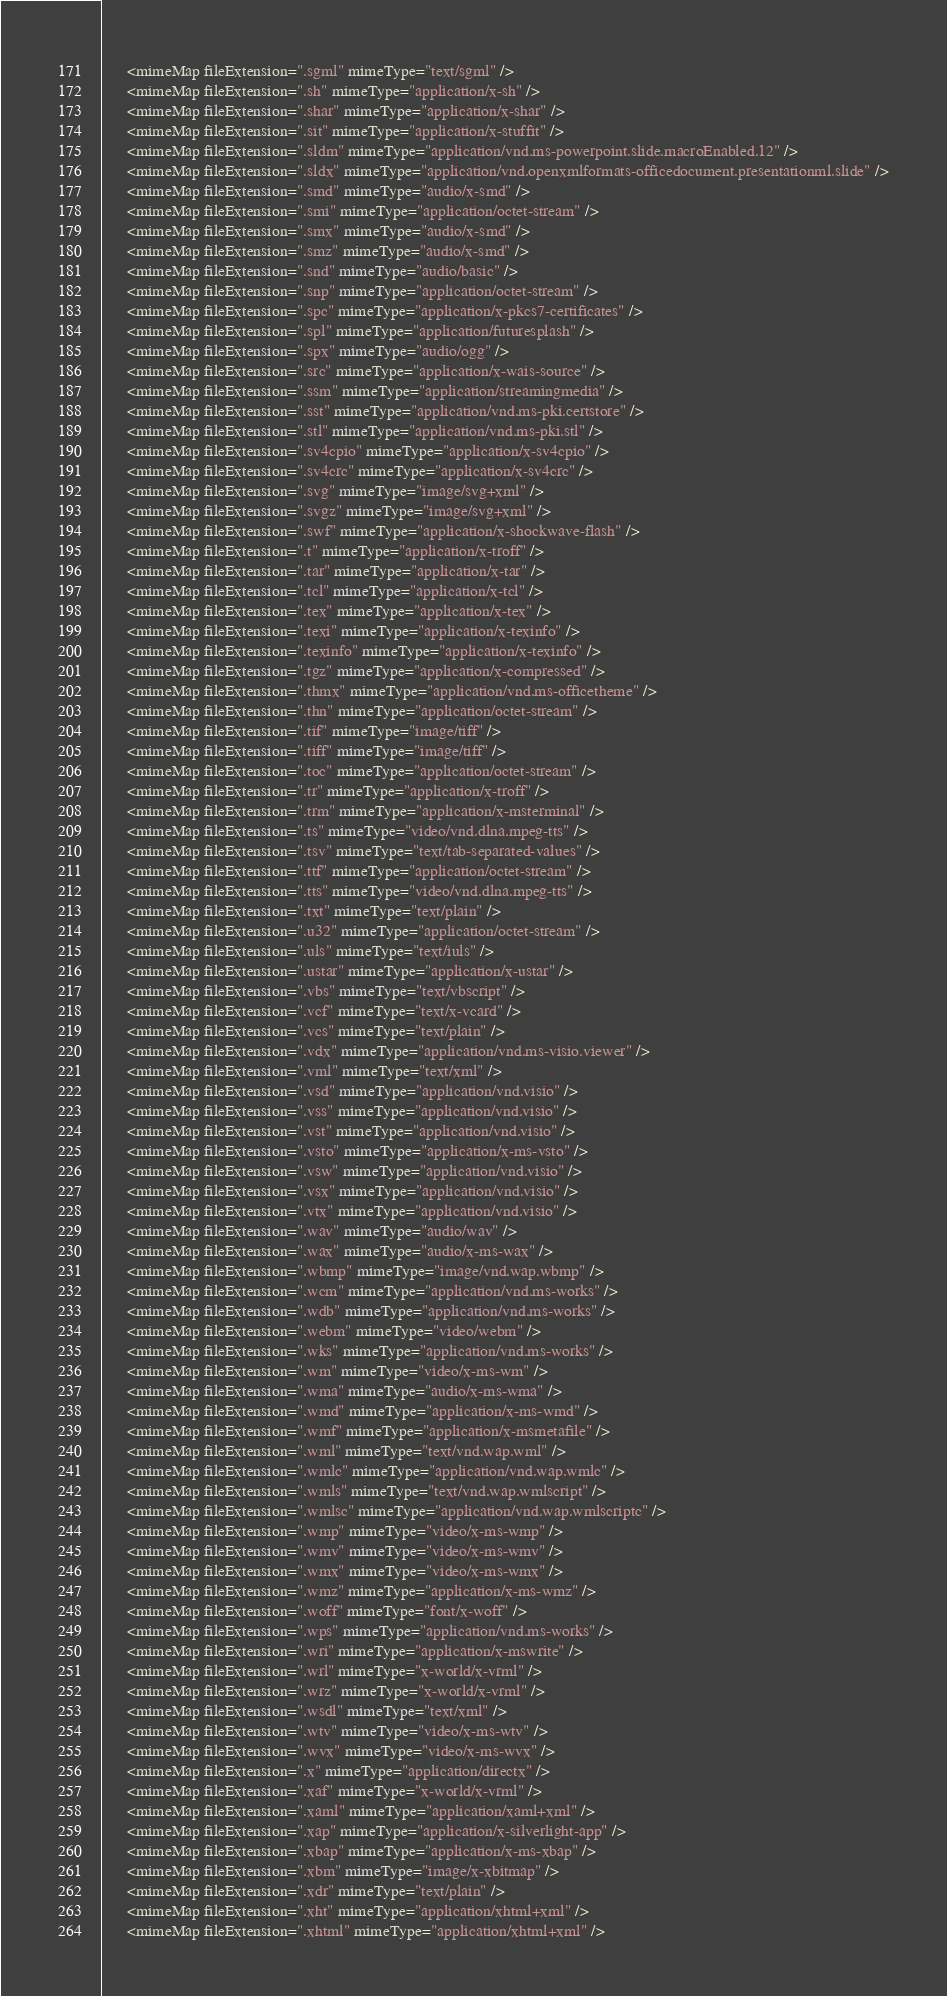Convert code to text. <code><loc_0><loc_0><loc_500><loc_500><_Go_>      <mimeMap fileExtension=".sgml" mimeType="text/sgml" />
      <mimeMap fileExtension=".sh" mimeType="application/x-sh" />
      <mimeMap fileExtension=".shar" mimeType="application/x-shar" />
      <mimeMap fileExtension=".sit" mimeType="application/x-stuffit" />
      <mimeMap fileExtension=".sldm" mimeType="application/vnd.ms-powerpoint.slide.macroEnabled.12" />
      <mimeMap fileExtension=".sldx" mimeType="application/vnd.openxmlformats-officedocument.presentationml.slide" />
      <mimeMap fileExtension=".smd" mimeType="audio/x-smd" />
      <mimeMap fileExtension=".smi" mimeType="application/octet-stream" />
      <mimeMap fileExtension=".smx" mimeType="audio/x-smd" />
      <mimeMap fileExtension=".smz" mimeType="audio/x-smd" />
      <mimeMap fileExtension=".snd" mimeType="audio/basic" />
      <mimeMap fileExtension=".snp" mimeType="application/octet-stream" />
      <mimeMap fileExtension=".spc" mimeType="application/x-pkcs7-certificates" />
      <mimeMap fileExtension=".spl" mimeType="application/futuresplash" />
      <mimeMap fileExtension=".spx" mimeType="audio/ogg" />
      <mimeMap fileExtension=".src" mimeType="application/x-wais-source" />
      <mimeMap fileExtension=".ssm" mimeType="application/streamingmedia" />
      <mimeMap fileExtension=".sst" mimeType="application/vnd.ms-pki.certstore" />
      <mimeMap fileExtension=".stl" mimeType="application/vnd.ms-pki.stl" />
      <mimeMap fileExtension=".sv4cpio" mimeType="application/x-sv4cpio" />
      <mimeMap fileExtension=".sv4crc" mimeType="application/x-sv4crc" />
      <mimeMap fileExtension=".svg" mimeType="image/svg+xml" />
      <mimeMap fileExtension=".svgz" mimeType="image/svg+xml" />
      <mimeMap fileExtension=".swf" mimeType="application/x-shockwave-flash" />
      <mimeMap fileExtension=".t" mimeType="application/x-troff" />
      <mimeMap fileExtension=".tar" mimeType="application/x-tar" />
      <mimeMap fileExtension=".tcl" mimeType="application/x-tcl" />
      <mimeMap fileExtension=".tex" mimeType="application/x-tex" />
      <mimeMap fileExtension=".texi" mimeType="application/x-texinfo" />
      <mimeMap fileExtension=".texinfo" mimeType="application/x-texinfo" />
      <mimeMap fileExtension=".tgz" mimeType="application/x-compressed" />
      <mimeMap fileExtension=".thmx" mimeType="application/vnd.ms-officetheme" />
      <mimeMap fileExtension=".thn" mimeType="application/octet-stream" />
      <mimeMap fileExtension=".tif" mimeType="image/tiff" />
      <mimeMap fileExtension=".tiff" mimeType="image/tiff" />
      <mimeMap fileExtension=".toc" mimeType="application/octet-stream" />
      <mimeMap fileExtension=".tr" mimeType="application/x-troff" />
      <mimeMap fileExtension=".trm" mimeType="application/x-msterminal" />
      <mimeMap fileExtension=".ts" mimeType="video/vnd.dlna.mpeg-tts" />
      <mimeMap fileExtension=".tsv" mimeType="text/tab-separated-values" />
      <mimeMap fileExtension=".ttf" mimeType="application/octet-stream" />
      <mimeMap fileExtension=".tts" mimeType="video/vnd.dlna.mpeg-tts" />
      <mimeMap fileExtension=".txt" mimeType="text/plain" />
      <mimeMap fileExtension=".u32" mimeType="application/octet-stream" />
      <mimeMap fileExtension=".uls" mimeType="text/iuls" />
      <mimeMap fileExtension=".ustar" mimeType="application/x-ustar" />
      <mimeMap fileExtension=".vbs" mimeType="text/vbscript" />
      <mimeMap fileExtension=".vcf" mimeType="text/x-vcard" />
      <mimeMap fileExtension=".vcs" mimeType="text/plain" />
      <mimeMap fileExtension=".vdx" mimeType="application/vnd.ms-visio.viewer" />
      <mimeMap fileExtension=".vml" mimeType="text/xml" />
      <mimeMap fileExtension=".vsd" mimeType="application/vnd.visio" />
      <mimeMap fileExtension=".vss" mimeType="application/vnd.visio" />
      <mimeMap fileExtension=".vst" mimeType="application/vnd.visio" />
      <mimeMap fileExtension=".vsto" mimeType="application/x-ms-vsto" />
      <mimeMap fileExtension=".vsw" mimeType="application/vnd.visio" />
      <mimeMap fileExtension=".vsx" mimeType="application/vnd.visio" />
      <mimeMap fileExtension=".vtx" mimeType="application/vnd.visio" />
      <mimeMap fileExtension=".wav" mimeType="audio/wav" />
      <mimeMap fileExtension=".wax" mimeType="audio/x-ms-wax" />
      <mimeMap fileExtension=".wbmp" mimeType="image/vnd.wap.wbmp" />
      <mimeMap fileExtension=".wcm" mimeType="application/vnd.ms-works" />
      <mimeMap fileExtension=".wdb" mimeType="application/vnd.ms-works" />
      <mimeMap fileExtension=".webm" mimeType="video/webm" />
      <mimeMap fileExtension=".wks" mimeType="application/vnd.ms-works" />
      <mimeMap fileExtension=".wm" mimeType="video/x-ms-wm" />
      <mimeMap fileExtension=".wma" mimeType="audio/x-ms-wma" />
      <mimeMap fileExtension=".wmd" mimeType="application/x-ms-wmd" />
      <mimeMap fileExtension=".wmf" mimeType="application/x-msmetafile" />
      <mimeMap fileExtension=".wml" mimeType="text/vnd.wap.wml" />
      <mimeMap fileExtension=".wmlc" mimeType="application/vnd.wap.wmlc" />
      <mimeMap fileExtension=".wmls" mimeType="text/vnd.wap.wmlscript" />
      <mimeMap fileExtension=".wmlsc" mimeType="application/vnd.wap.wmlscriptc" />
      <mimeMap fileExtension=".wmp" mimeType="video/x-ms-wmp" />
      <mimeMap fileExtension=".wmv" mimeType="video/x-ms-wmv" />
      <mimeMap fileExtension=".wmx" mimeType="video/x-ms-wmx" />
      <mimeMap fileExtension=".wmz" mimeType="application/x-ms-wmz" />
      <mimeMap fileExtension=".woff" mimeType="font/x-woff" />
      <mimeMap fileExtension=".wps" mimeType="application/vnd.ms-works" />
      <mimeMap fileExtension=".wri" mimeType="application/x-mswrite" />
      <mimeMap fileExtension=".wrl" mimeType="x-world/x-vrml" />
      <mimeMap fileExtension=".wrz" mimeType="x-world/x-vrml" />
      <mimeMap fileExtension=".wsdl" mimeType="text/xml" />
      <mimeMap fileExtension=".wtv" mimeType="video/x-ms-wtv" />
      <mimeMap fileExtension=".wvx" mimeType="video/x-ms-wvx" />
      <mimeMap fileExtension=".x" mimeType="application/directx" />
      <mimeMap fileExtension=".xaf" mimeType="x-world/x-vrml" />
      <mimeMap fileExtension=".xaml" mimeType="application/xaml+xml" />
      <mimeMap fileExtension=".xap" mimeType="application/x-silverlight-app" />
      <mimeMap fileExtension=".xbap" mimeType="application/x-ms-xbap" />
      <mimeMap fileExtension=".xbm" mimeType="image/x-xbitmap" />
      <mimeMap fileExtension=".xdr" mimeType="text/plain" />
      <mimeMap fileExtension=".xht" mimeType="application/xhtml+xml" />
      <mimeMap fileExtension=".xhtml" mimeType="application/xhtml+xml" /></code> 